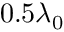Convert formula to latex. <formula><loc_0><loc_0><loc_500><loc_500>0 . 5 \lambda _ { 0 }</formula> 